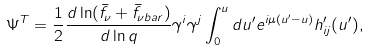Convert formula to latex. <formula><loc_0><loc_0><loc_500><loc_500>\Psi ^ { T } = \frac { 1 } { 2 } \frac { d \ln ( \bar { f } _ { \nu } + \bar { f } _ { \nu b a r } ) } { d \ln q } \gamma ^ { i } \gamma ^ { j } \int ^ { u } _ { 0 } d u ^ { \prime } e ^ { i \mu ( u ^ { \prime } - u ) } h ^ { \prime } _ { i j } ( u ^ { \prime } ) ,</formula> 